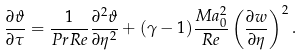<formula> <loc_0><loc_0><loc_500><loc_500>\frac { \partial \vartheta } { \partial \tau } = \frac { 1 } { P r R e } \frac { \partial ^ { 2 } \vartheta } { \partial \eta ^ { 2 } } + ( \gamma - 1 ) \frac { M a _ { 0 } ^ { 2 } } { R e } \left ( \frac { \partial w } { \partial \eta } \right ) ^ { 2 } .</formula> 